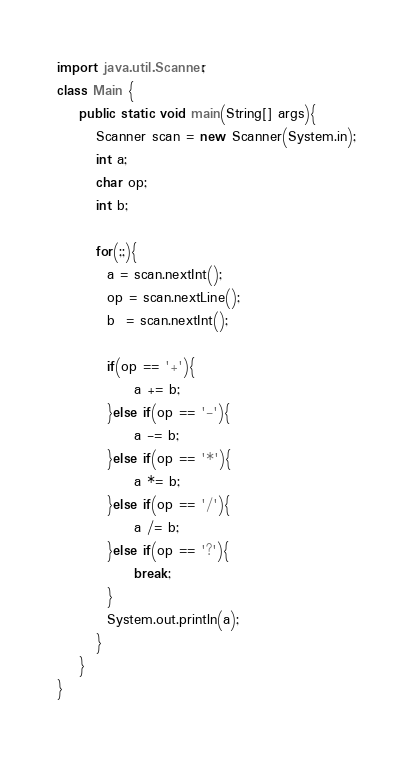<code> <loc_0><loc_0><loc_500><loc_500><_Java_>import java.util.Scanner;
class Main {
    public static void main(String[] args){
       Scanner scan = new Scanner(System.in);
       int a;
       char op;
       int b;
       
       for(;;){  
         a = scan.nextInt();
         op = scan.nextLine();
         b  = scan.nextInt();
         
         if(op == '+'){
              a += b;
         }else if(op == '-'){
              a -= b;
         }else if(op == '*'){
              a *= b;
         }else if(op == '/'){
              a /= b;
         }else if(op == '?'){
              break;
         }
         System.out.println(a);
       }
    }
}</code> 